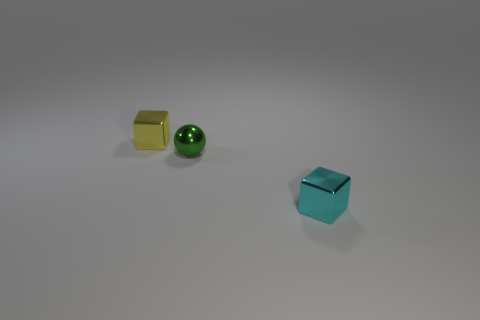Add 3 yellow matte balls. How many objects exist? 6 Subtract all balls. How many objects are left? 2 Add 1 green metallic spheres. How many green metallic spheres are left? 2 Add 1 green matte blocks. How many green matte blocks exist? 1 Subtract 0 cyan spheres. How many objects are left? 3 Subtract all tiny yellow shiny objects. Subtract all tiny green objects. How many objects are left? 1 